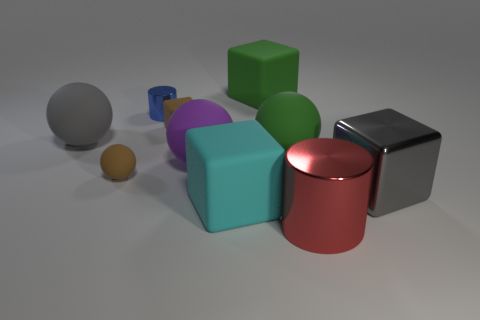There is a tiny brown object in front of the small brown cube; what is it made of?
Your answer should be compact. Rubber. There is a shiny thing that is left of the gray block and on the right side of the blue object; what shape is it?
Your answer should be very brief. Cylinder. What is the material of the tiny blue thing?
Your answer should be very brief. Metal. What number of cylinders are gray things or shiny things?
Offer a very short reply. 2. Are the brown cube and the small blue thing made of the same material?
Your answer should be very brief. No. There is a gray metal thing that is the same shape as the large cyan object; what is its size?
Keep it short and to the point. Large. The thing that is to the left of the large green sphere and in front of the large gray metal object is made of what material?
Offer a terse response. Rubber. Are there an equal number of green matte balls that are behind the brown rubber block and large cyan metal cubes?
Your answer should be very brief. Yes. What number of objects are either things that are left of the red object or big cylinders?
Make the answer very short. 9. Does the metal cylinder that is behind the large gray block have the same color as the big shiny block?
Make the answer very short. No. 